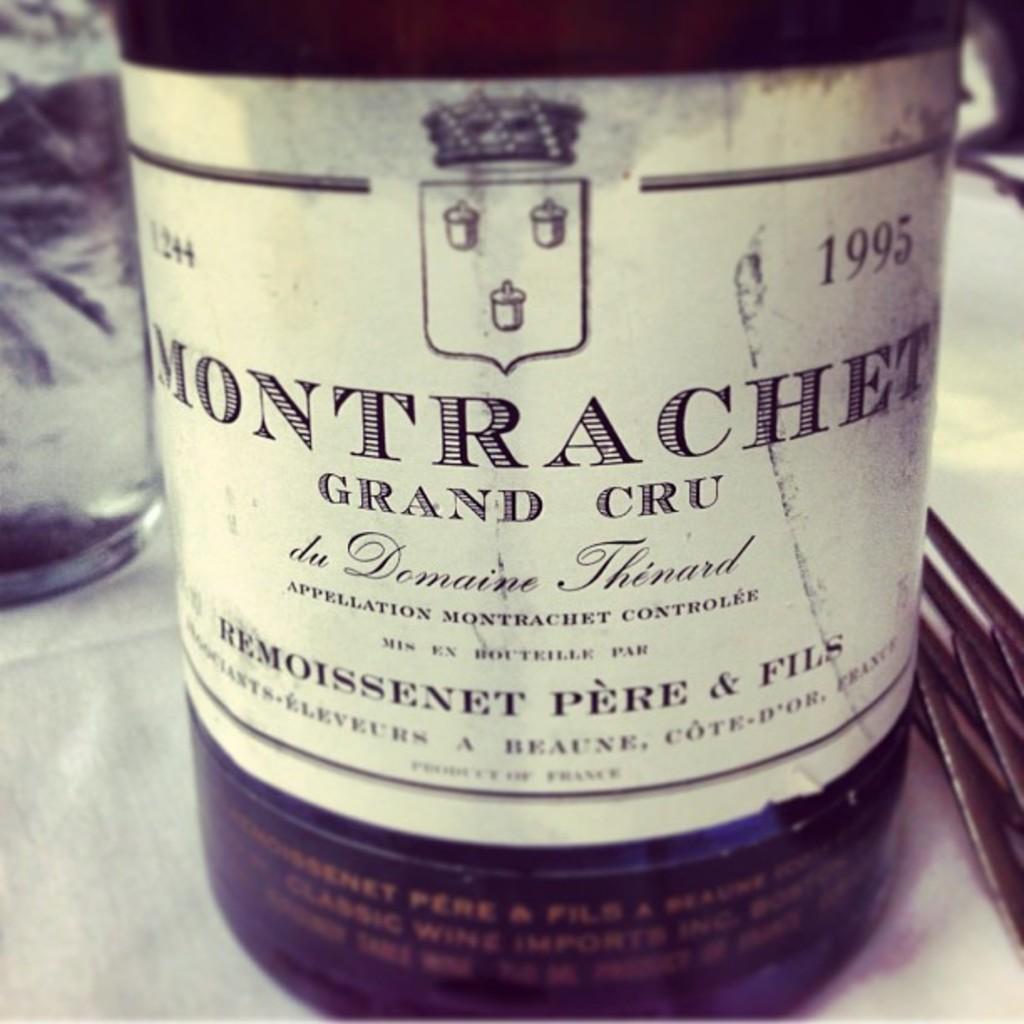What kind of wine is this?
Provide a succinct answer. Grand cru. What year was it bottled?
Your response must be concise. 1995. 